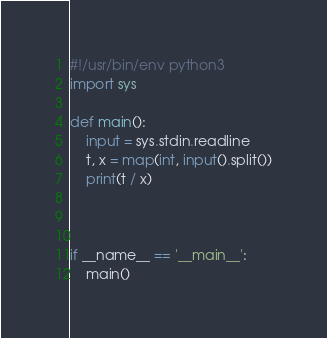<code> <loc_0><loc_0><loc_500><loc_500><_Python_>#!/usr/bin/env python3
import sys

def main():
    input = sys.stdin.readline
    t, x = map(int, input().split())
    print(t / x)



if __name__ == '__main__':
    main()
</code> 